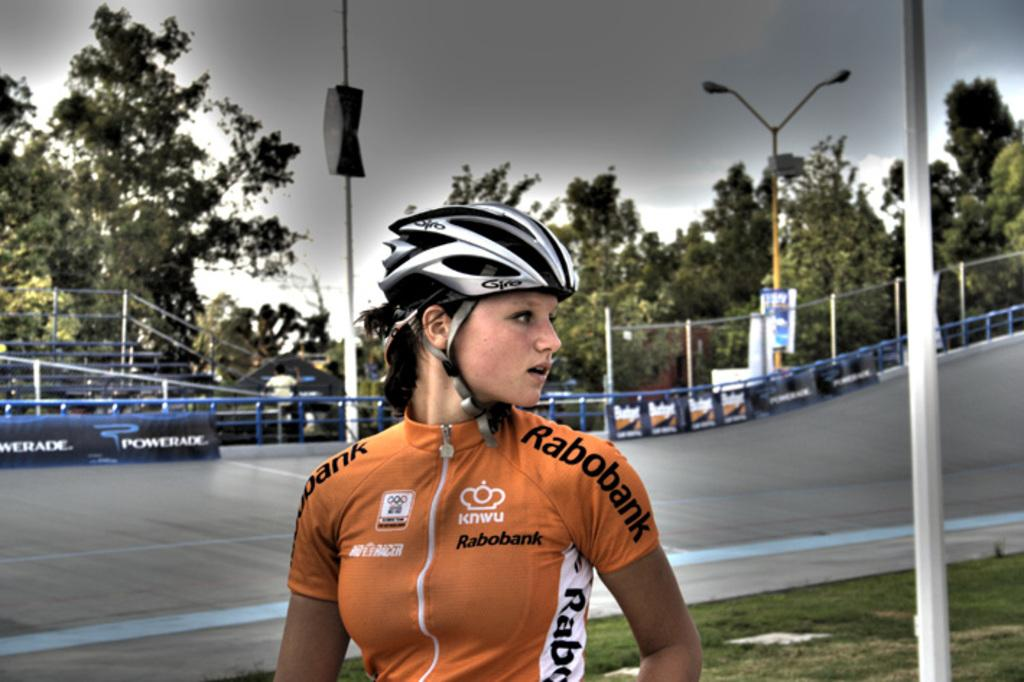Who is present in the image? There is a woman in the image. What is the woman wearing on her head? The woman is wearing a helmet. What type of terrain is visible in the image? There is grass in the image. What structures can be seen in the background? There is a pole, fences, trees, a board, multiple poles, and a banner in the background of the image. What is the condition of the sky in the image? The sky is cloudy in the background of the image. How many chairs are visible in the image? There are no chairs present in the image. What type of thumb is the woman using to hold the pole in the image? The woman is not holding a pole in the image, and there is no mention of a thumb. What role does the governor play in the image? There is no mention of a governor in the image or the provided facts. 